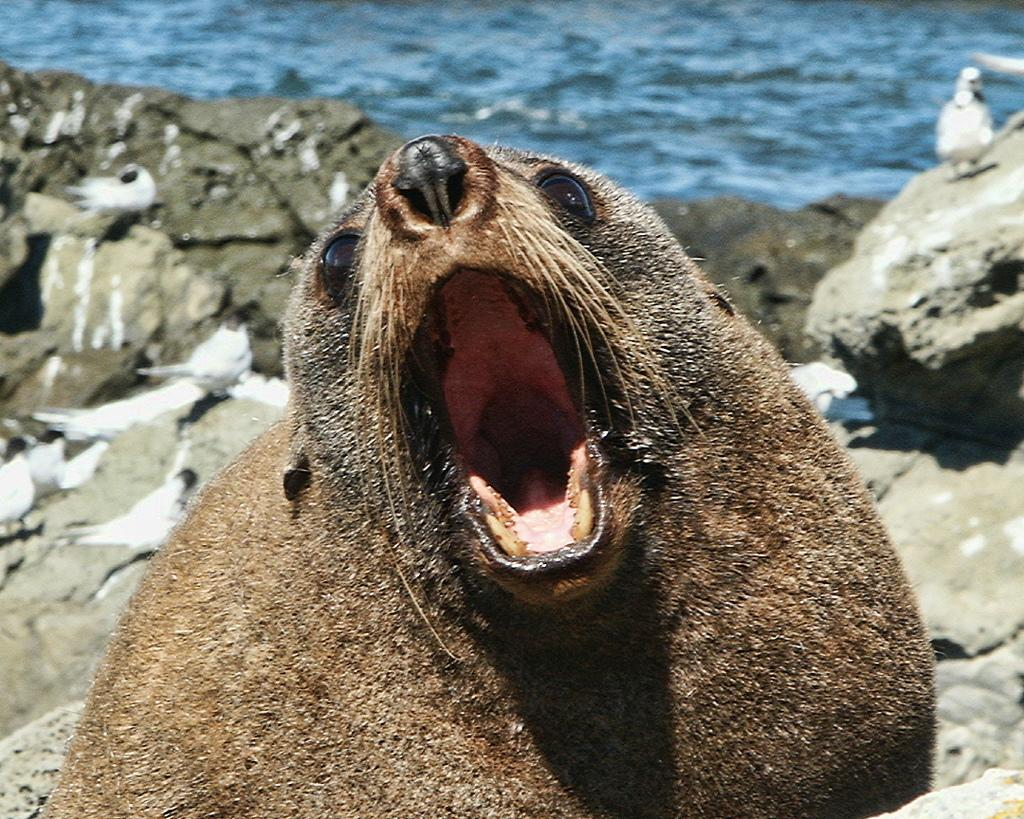What type of animal is in the image? The type of animal cannot be determined from the provided facts. What is the animal doing in the image? The animal is opening its mouth in the image. What can be seen in the background of the image? There is blue color water in the background of the image. What type of farmer is standing next to the animal in the image? There is no farmer present in the image. How many steps does the sponge take to reach the animal in the image? There is no sponge present in the image. 